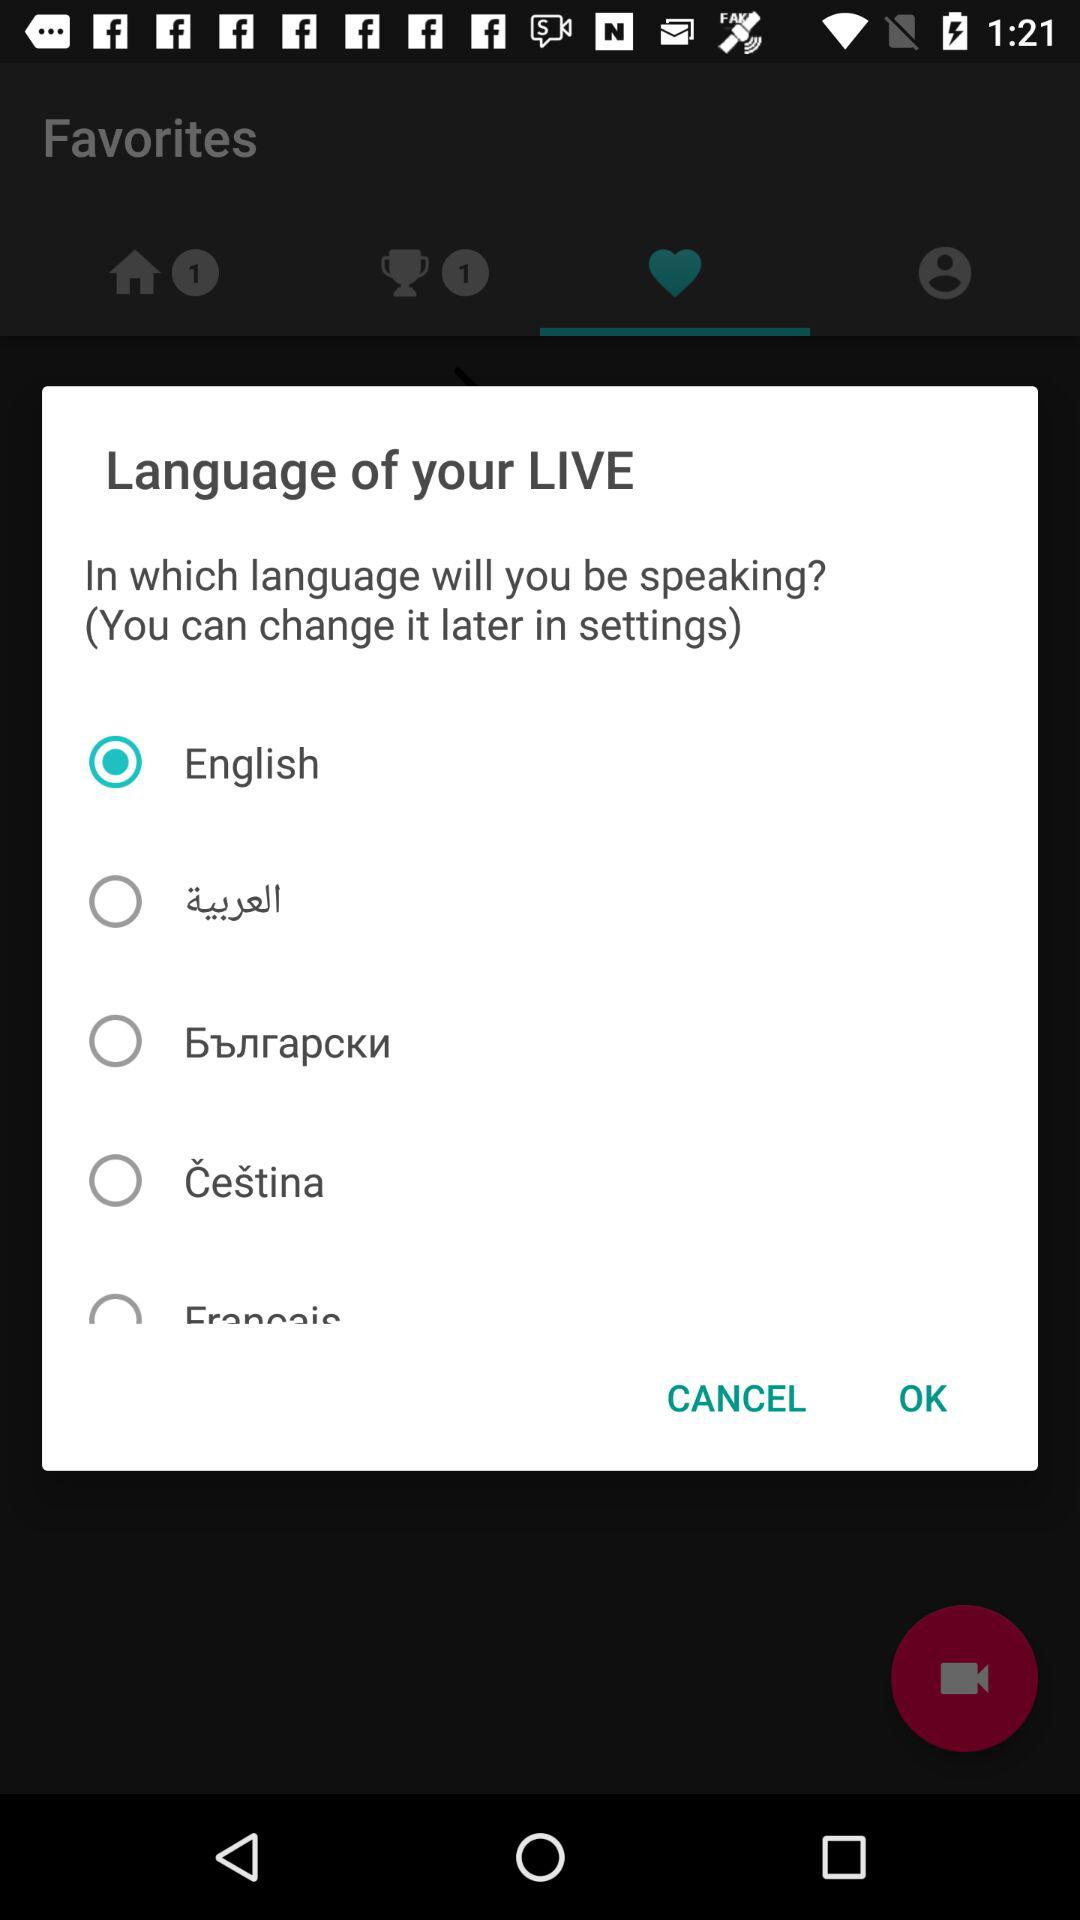What is the selected language for speaking? The selected language for speaking is English. 